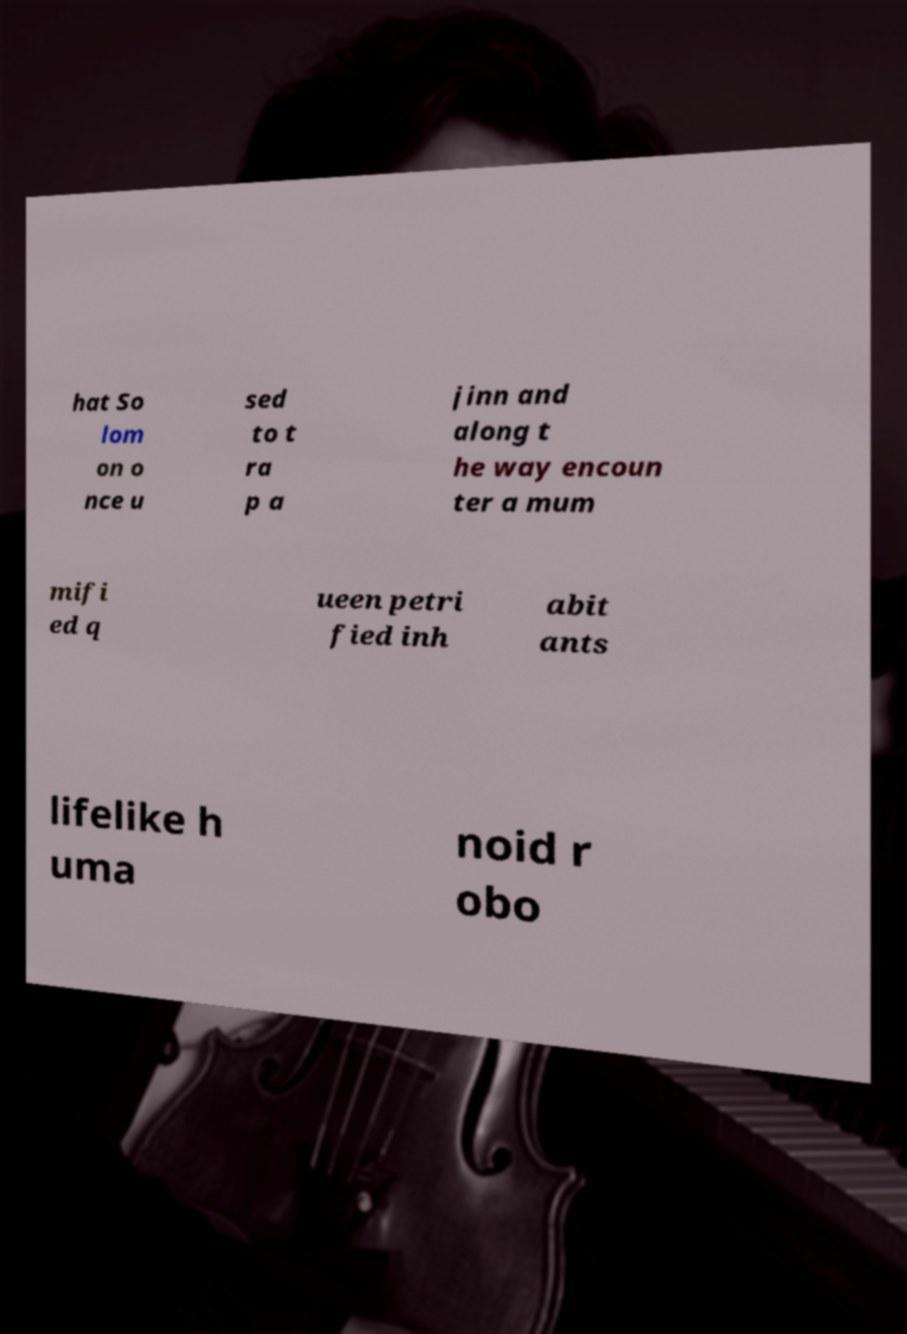Can you read and provide the text displayed in the image?This photo seems to have some interesting text. Can you extract and type it out for me? hat So lom on o nce u sed to t ra p a jinn and along t he way encoun ter a mum mifi ed q ueen petri fied inh abit ants lifelike h uma noid r obo 